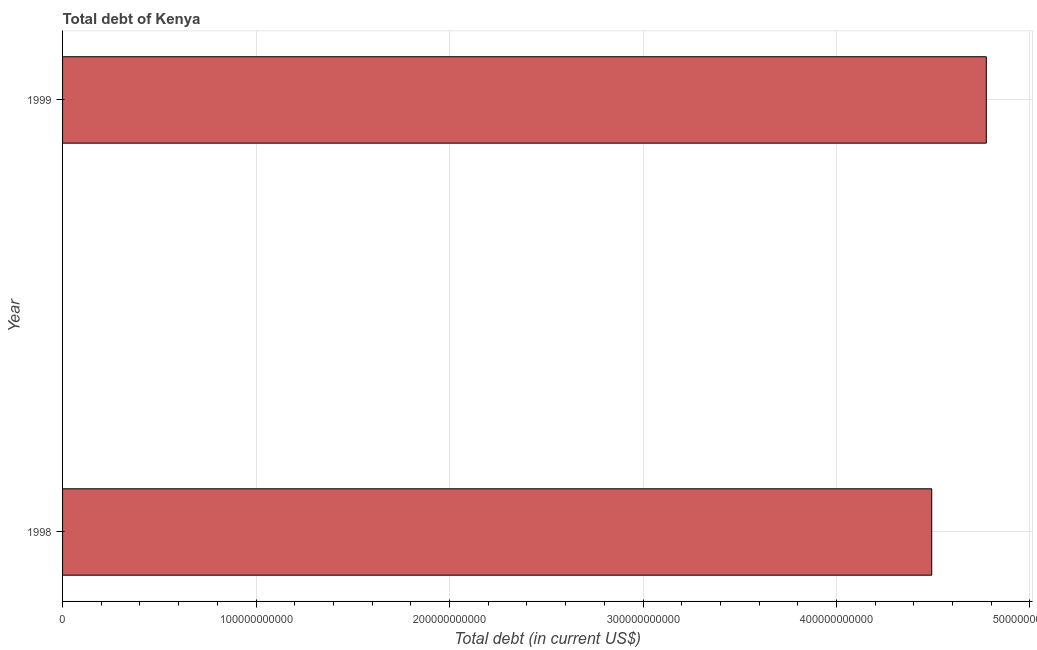Does the graph contain any zero values?
Provide a succinct answer. No. Does the graph contain grids?
Provide a succinct answer. Yes. What is the title of the graph?
Make the answer very short. Total debt of Kenya. What is the label or title of the X-axis?
Give a very brief answer. Total debt (in current US$). What is the total debt in 1998?
Keep it short and to the point. 4.49e+11. Across all years, what is the maximum total debt?
Provide a succinct answer. 4.77e+11. Across all years, what is the minimum total debt?
Make the answer very short. 4.49e+11. In which year was the total debt maximum?
Provide a succinct answer. 1999. What is the sum of the total debt?
Keep it short and to the point. 9.27e+11. What is the difference between the total debt in 1998 and 1999?
Keep it short and to the point. -2.82e+1. What is the average total debt per year?
Keep it short and to the point. 4.63e+11. What is the median total debt?
Your answer should be compact. 4.63e+11. What is the ratio of the total debt in 1998 to that in 1999?
Your response must be concise. 0.94. In how many years, is the total debt greater than the average total debt taken over all years?
Offer a very short reply. 1. How many bars are there?
Provide a short and direct response. 2. Are all the bars in the graph horizontal?
Your answer should be compact. Yes. What is the difference between two consecutive major ticks on the X-axis?
Offer a terse response. 1.00e+11. Are the values on the major ticks of X-axis written in scientific E-notation?
Offer a very short reply. No. What is the Total debt (in current US$) in 1998?
Provide a short and direct response. 4.49e+11. What is the Total debt (in current US$) in 1999?
Keep it short and to the point. 4.77e+11. What is the difference between the Total debt (in current US$) in 1998 and 1999?
Provide a short and direct response. -2.82e+1. What is the ratio of the Total debt (in current US$) in 1998 to that in 1999?
Keep it short and to the point. 0.94. 